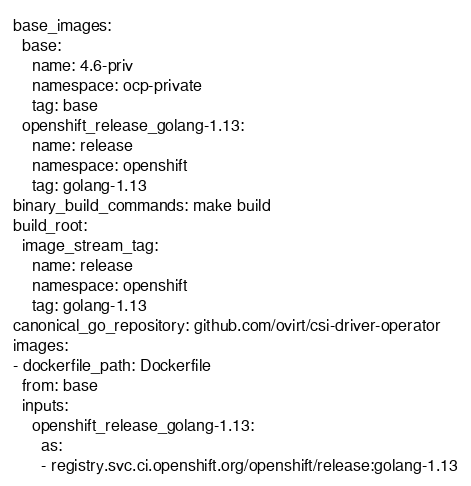<code> <loc_0><loc_0><loc_500><loc_500><_YAML_>base_images:
  base:
    name: 4.6-priv
    namespace: ocp-private
    tag: base
  openshift_release_golang-1.13:
    name: release
    namespace: openshift
    tag: golang-1.13
binary_build_commands: make build
build_root:
  image_stream_tag:
    name: release
    namespace: openshift
    tag: golang-1.13
canonical_go_repository: github.com/ovirt/csi-driver-operator
images:
- dockerfile_path: Dockerfile
  from: base
  inputs:
    openshift_release_golang-1.13:
      as:
      - registry.svc.ci.openshift.org/openshift/release:golang-1.13</code> 